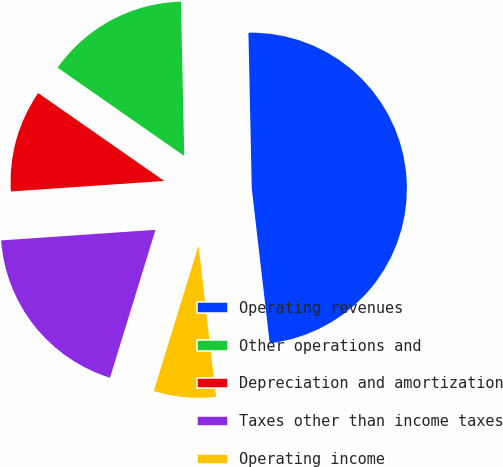Convert chart to OTSL. <chart><loc_0><loc_0><loc_500><loc_500><pie_chart><fcel>Operating revenues<fcel>Other operations and<fcel>Depreciation and amortization<fcel>Taxes other than income taxes<fcel>Operating income<nl><fcel>48.5%<fcel>14.97%<fcel>10.78%<fcel>19.16%<fcel>6.59%<nl></chart> 